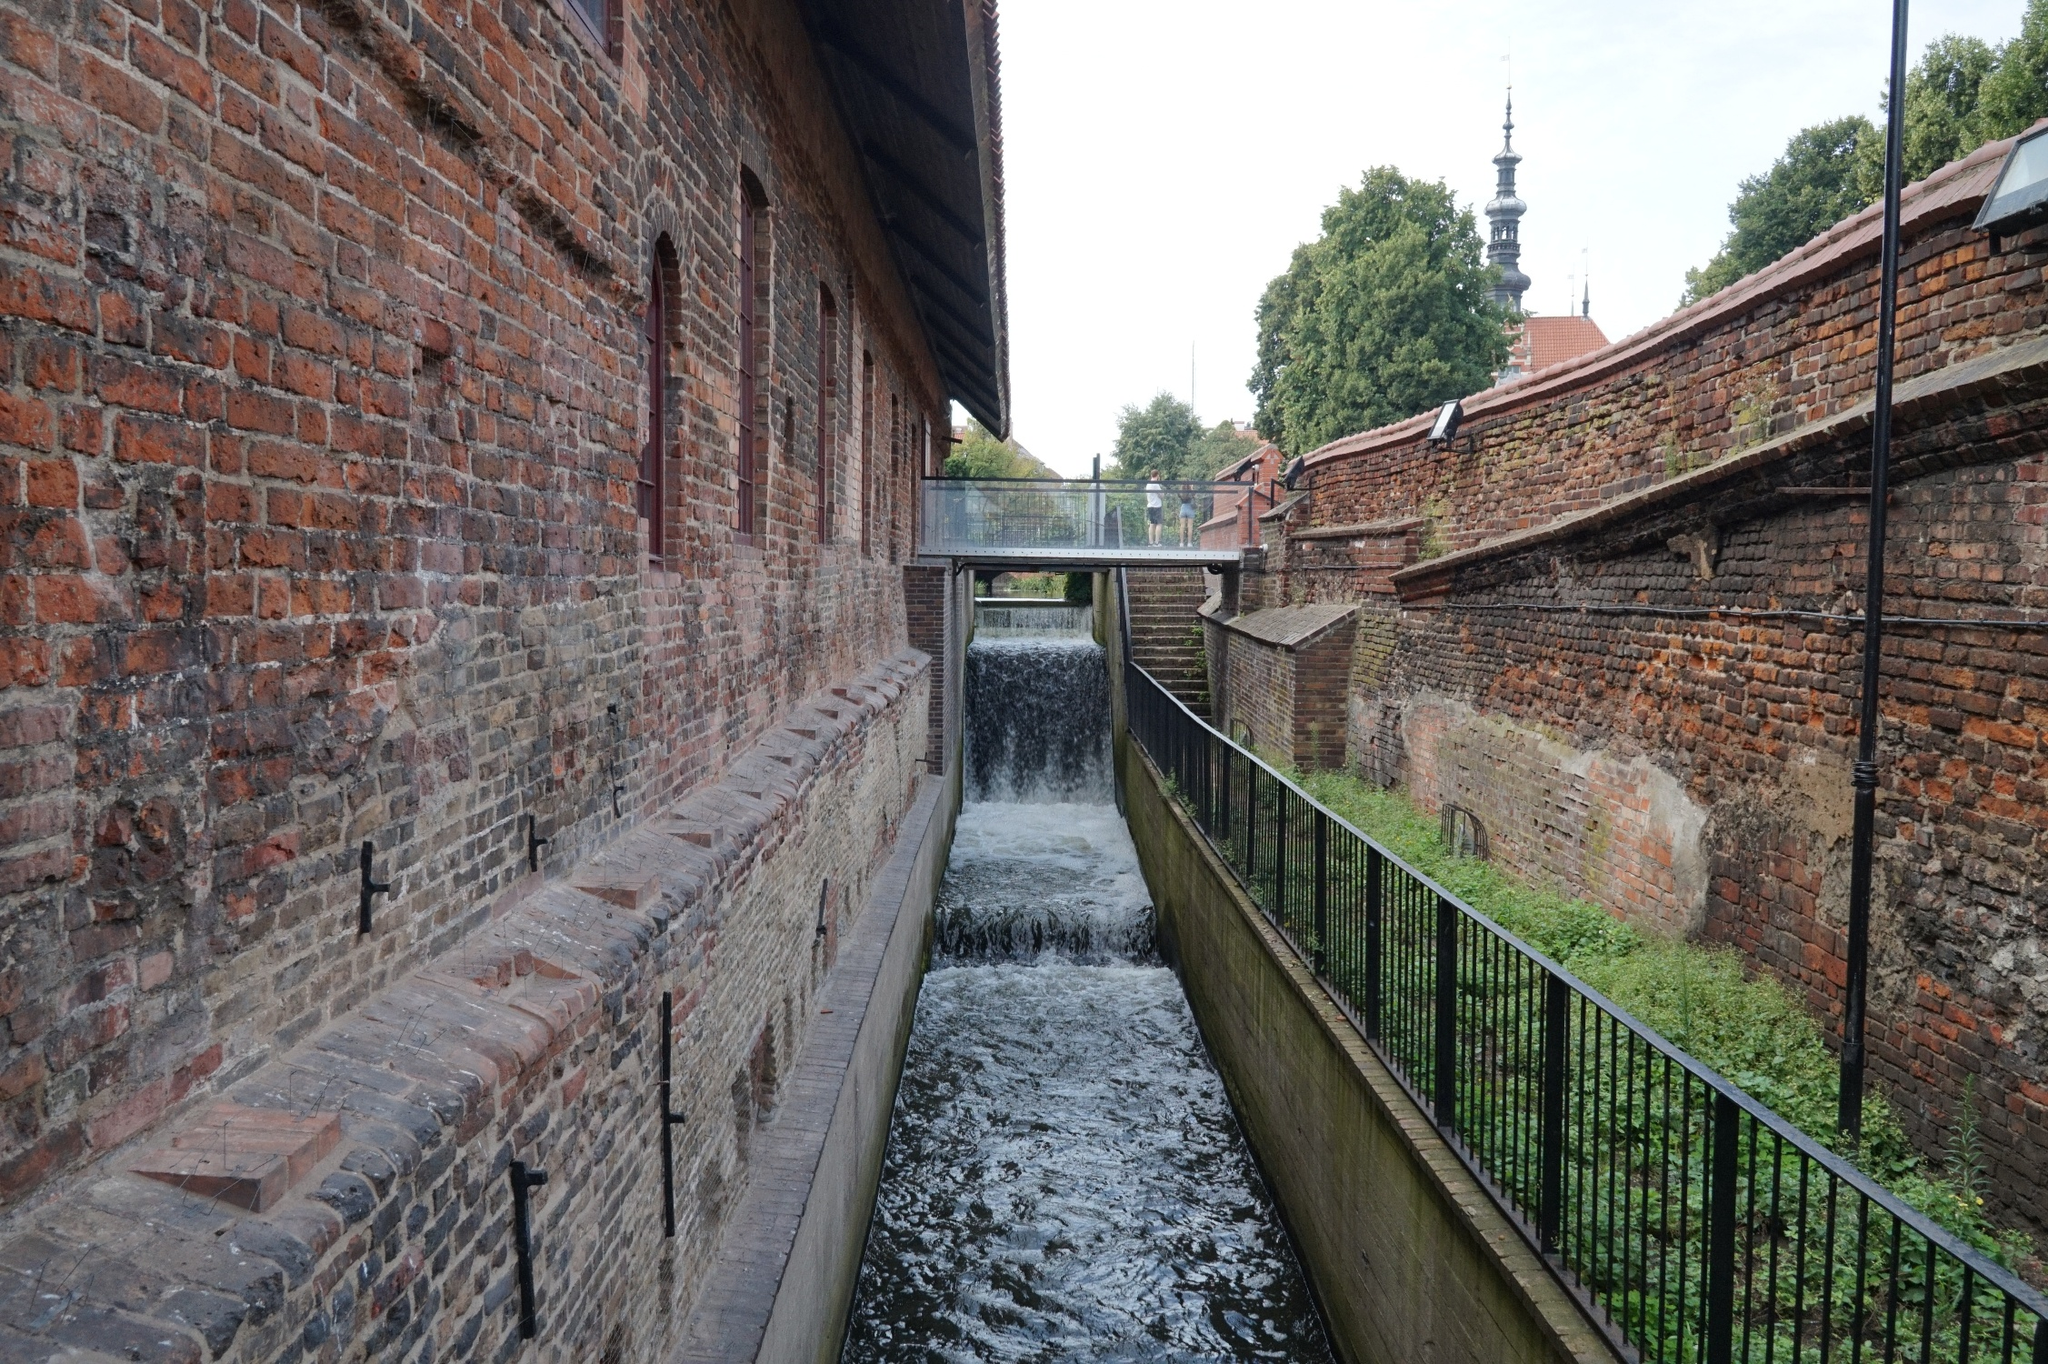Suppose this place was a movie set. What kind of scenes would be perfect to shoot here? This location would be perfect for shooting scenes in a period drama, an urban adventure, or a mystery film. The brick building and canal could serve as the backdrop for clandestine meetings, thrilling chases along the narrow walkway, or serene, introspective moments by the water. The small waterfall adds a dynamic element, ideal for scenes of discovery or escape. The church spire in the background could hint at larger secrets within the town, perfect for a subplot involving historical mysteries. 